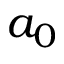Convert formula to latex. <formula><loc_0><loc_0><loc_500><loc_500>a _ { 0 }</formula> 